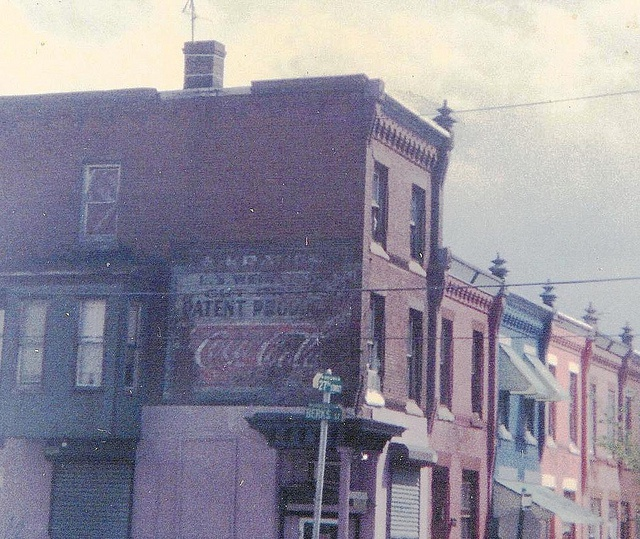Describe the objects in this image and their specific colors. I can see various objects in this image with different colors. 